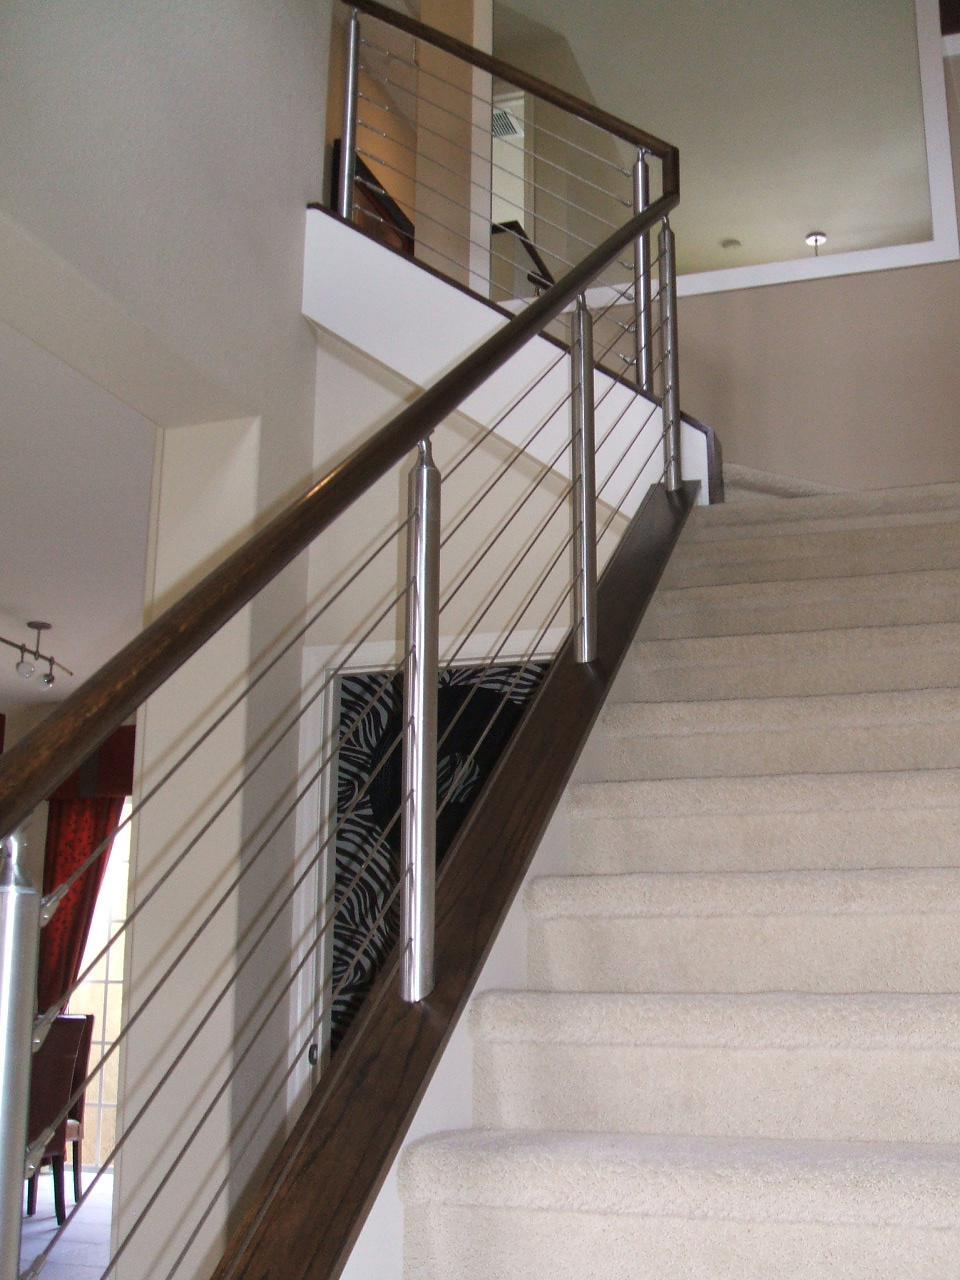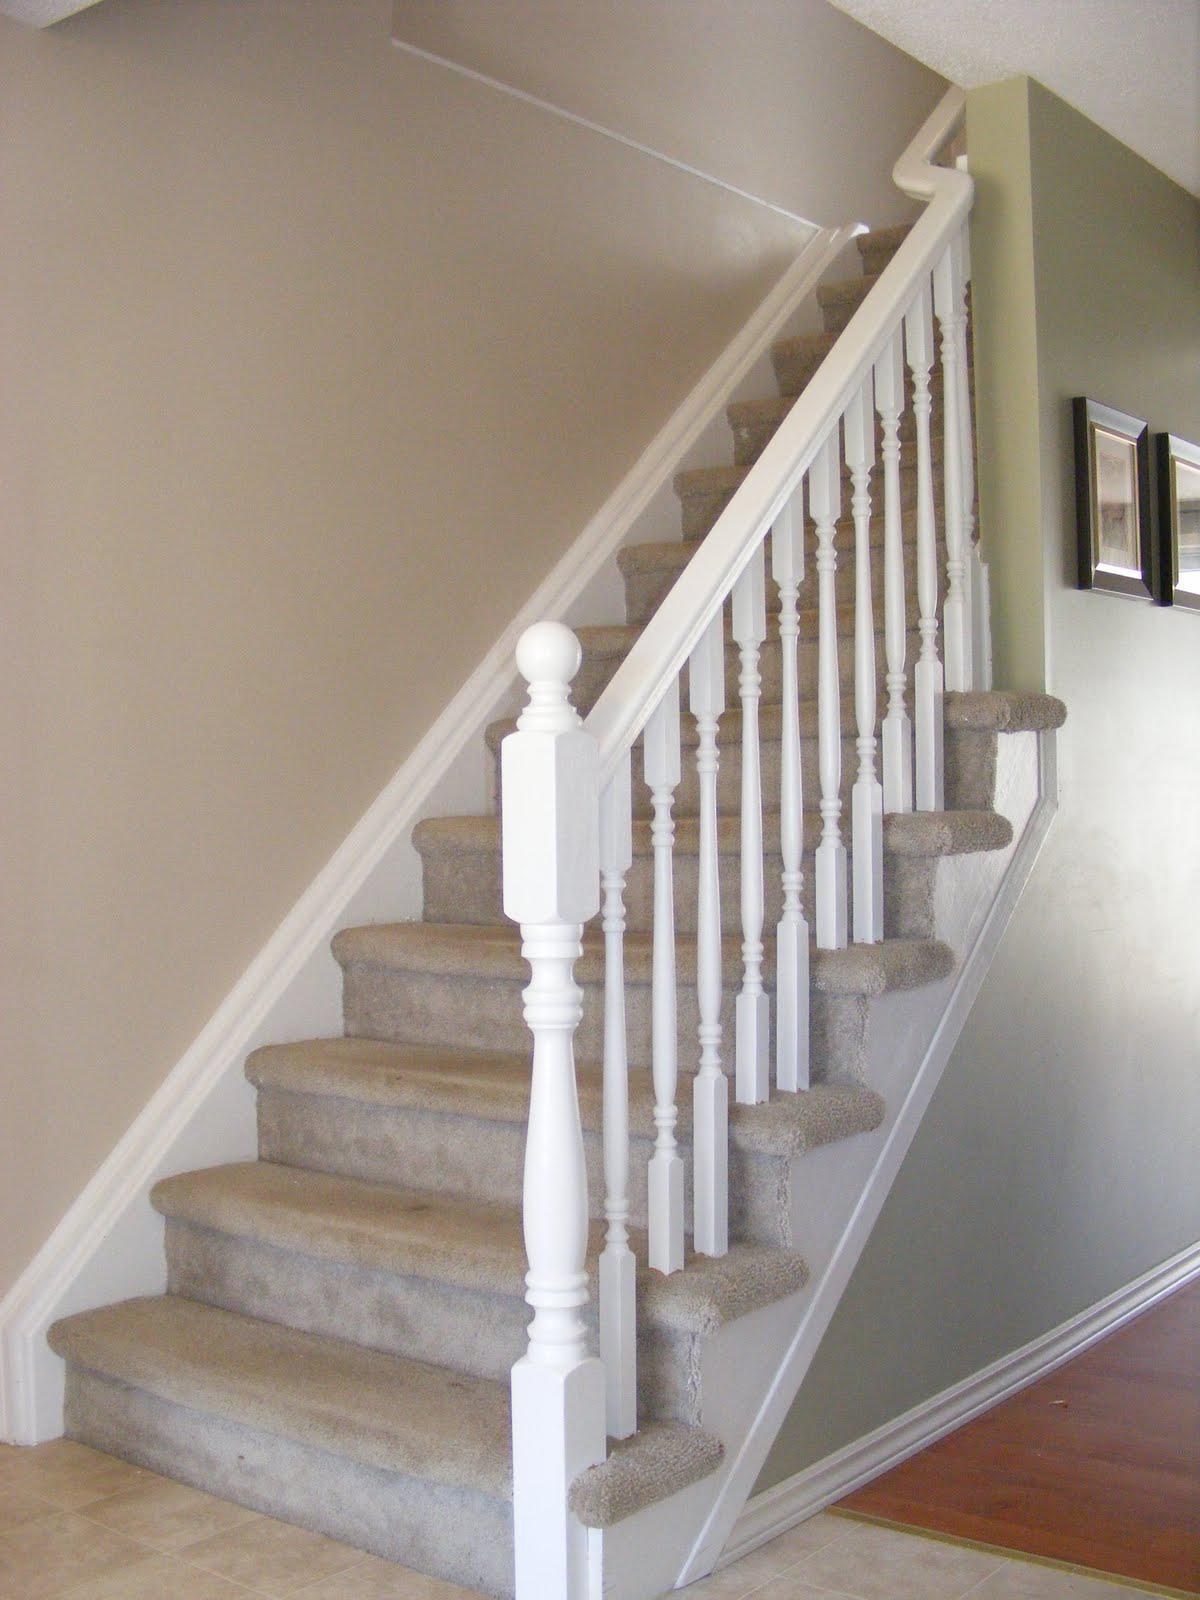The first image is the image on the left, the second image is the image on the right. Analyze the images presented: Is the assertion "In at least one image there are right facing stairs with black arm rails and white painted rods keeping it up." valid? Answer yes or no. No. The first image is the image on the left, the second image is the image on the right. For the images shown, is this caption "Each image shows a staircase that ascends to the right and has a wooden banister with only vertical bars and a closed-in bottom." true? Answer yes or no. No. 